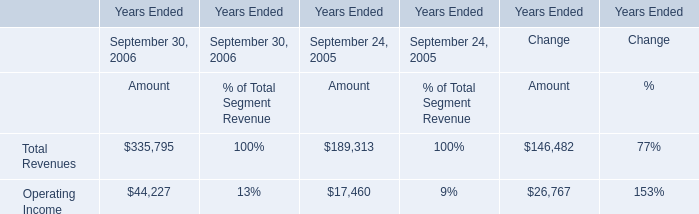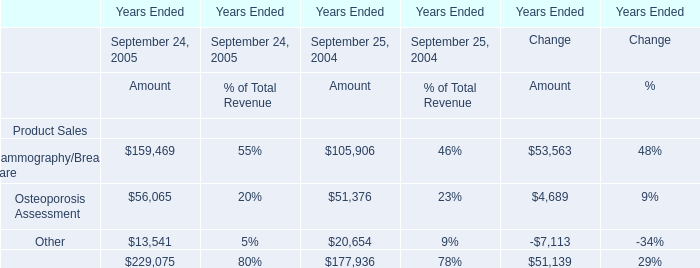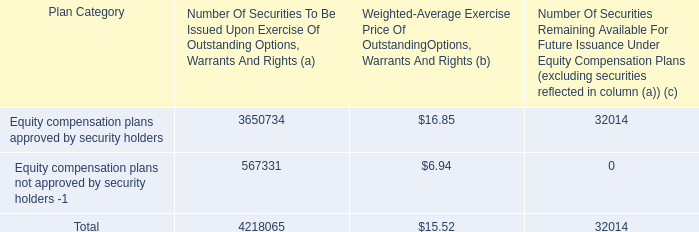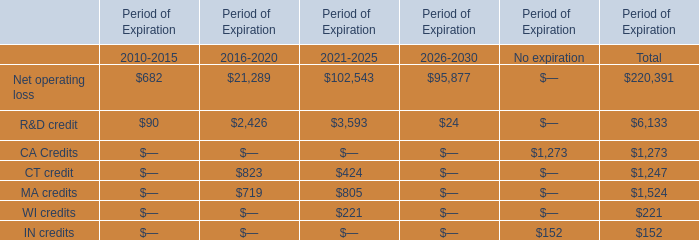What was the total amount of Period of Expiration in the range of 200 and 500 in 2021-2025? 
Computations: (424 + 221)
Answer: 645.0. 